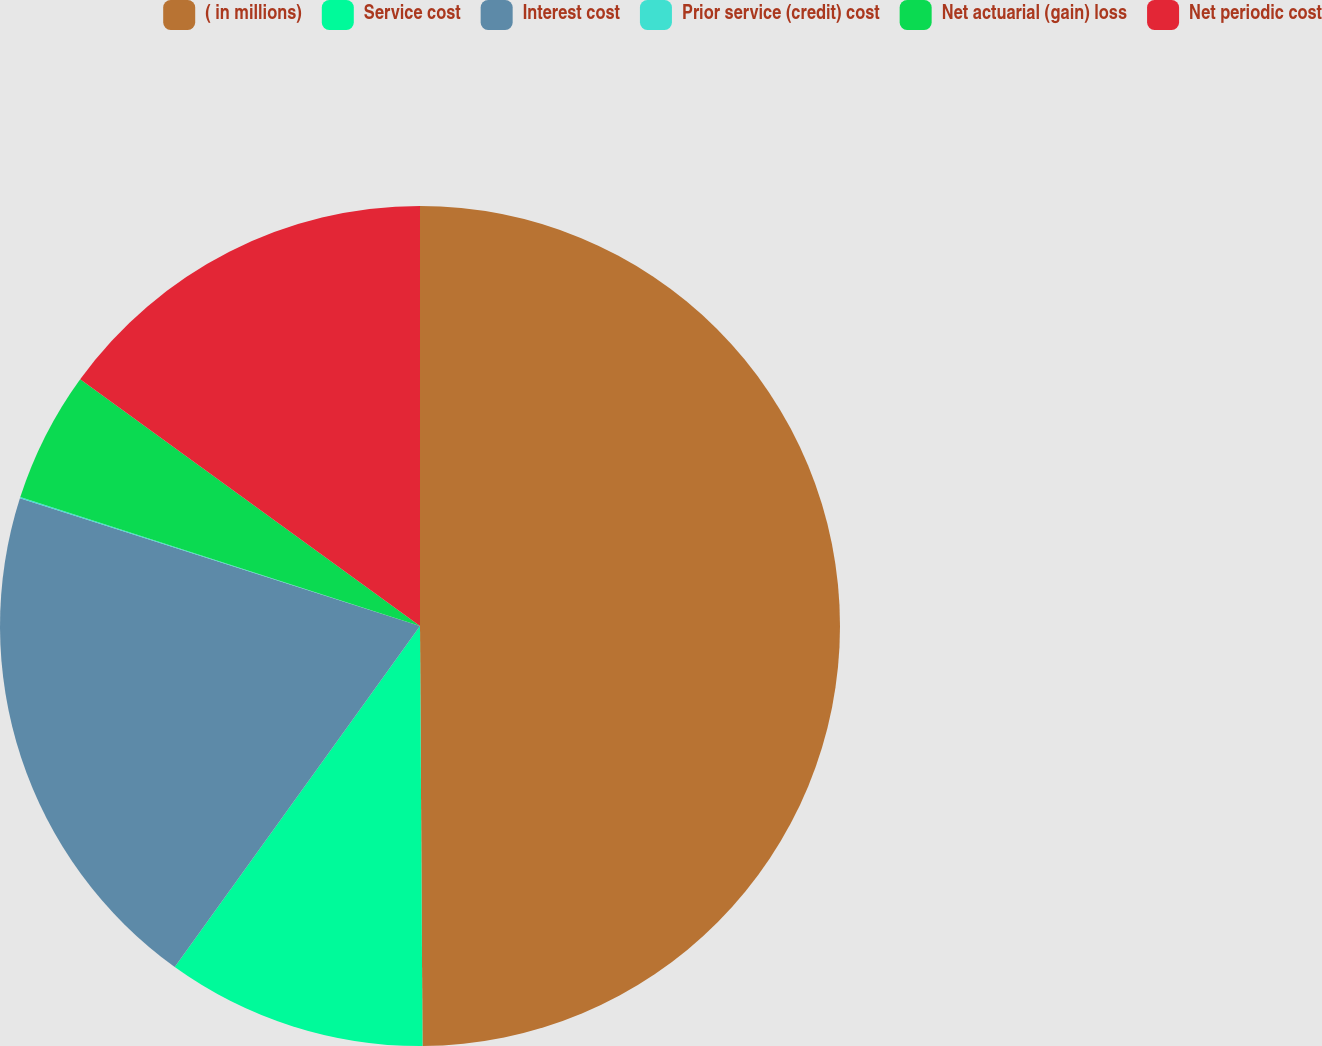<chart> <loc_0><loc_0><loc_500><loc_500><pie_chart><fcel>( in millions)<fcel>Service cost<fcel>Interest cost<fcel>Prior service (credit) cost<fcel>Net actuarial (gain) loss<fcel>Net periodic cost<nl><fcel>49.9%<fcel>10.02%<fcel>19.99%<fcel>0.05%<fcel>5.03%<fcel>15.0%<nl></chart> 